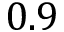Convert formula to latex. <formula><loc_0><loc_0><loc_500><loc_500>0 . 9</formula> 